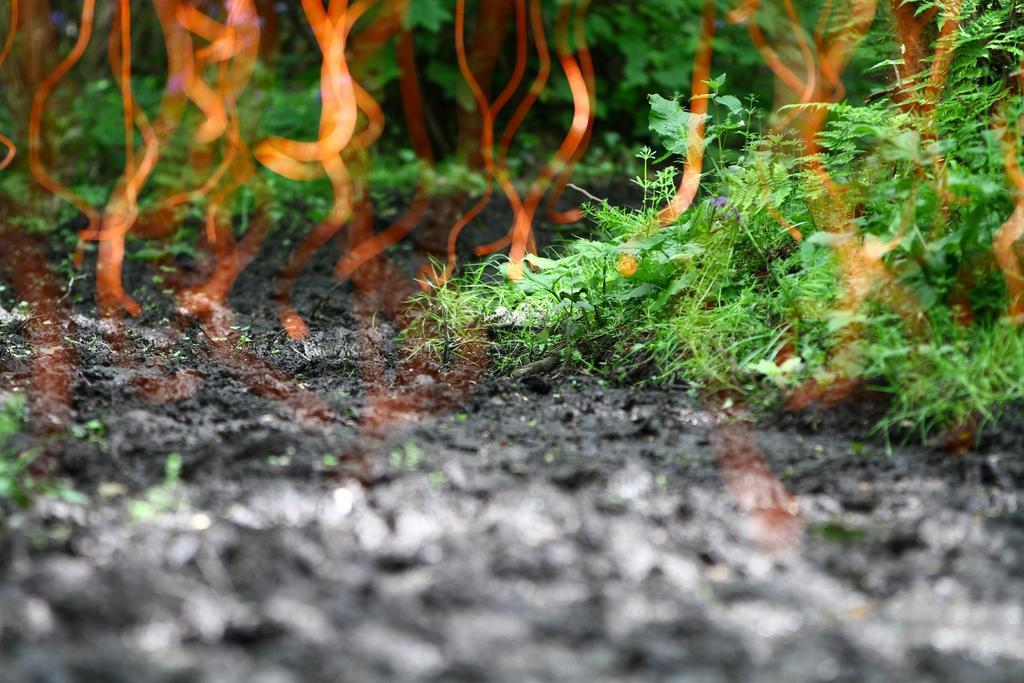What type of living organisms can be seen in the image? There is a group of plants in the image. What is the other significant element in the image? There is fire in the image. What type of debt is being discussed in the image? There is no mention of debt in the image; it features a group of plants and fire. What kind of structure can be seen in the image? There is no structure present in the image; it only features a group of plants and fire. 